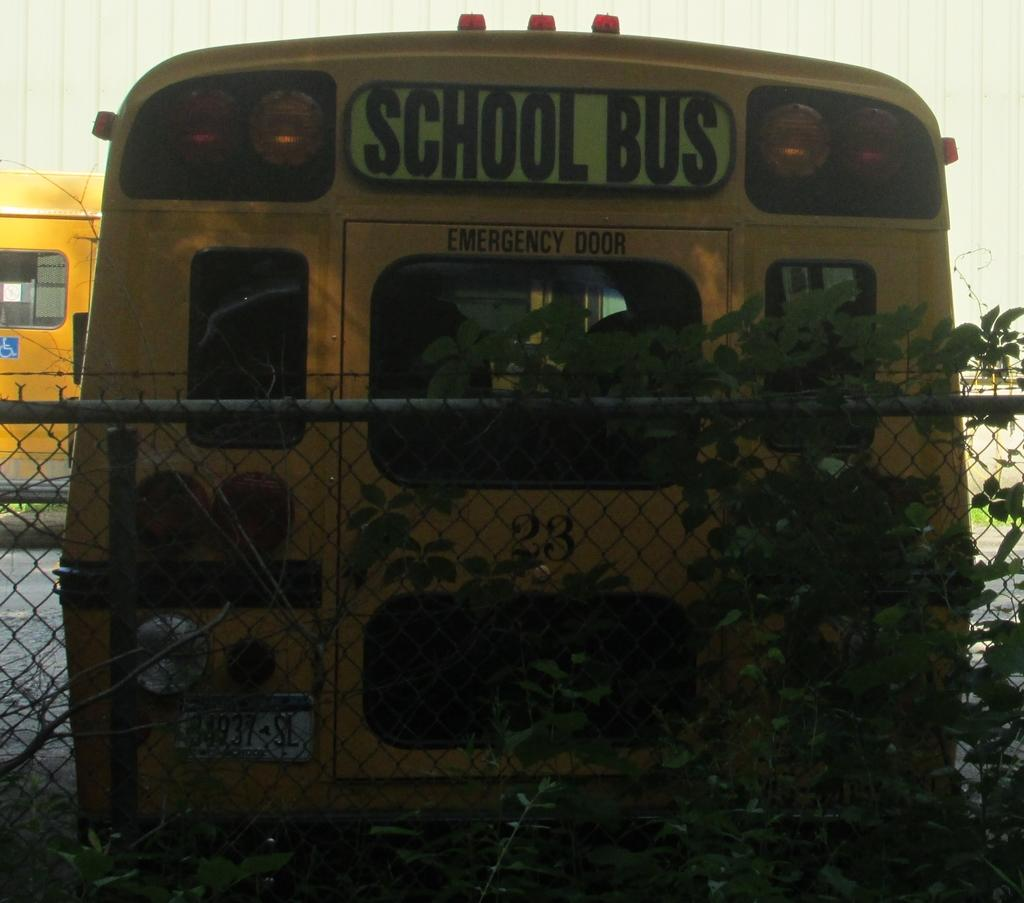<image>
Share a concise interpretation of the image provided. The school bus shown behind the fence has an emergency door at the back. 